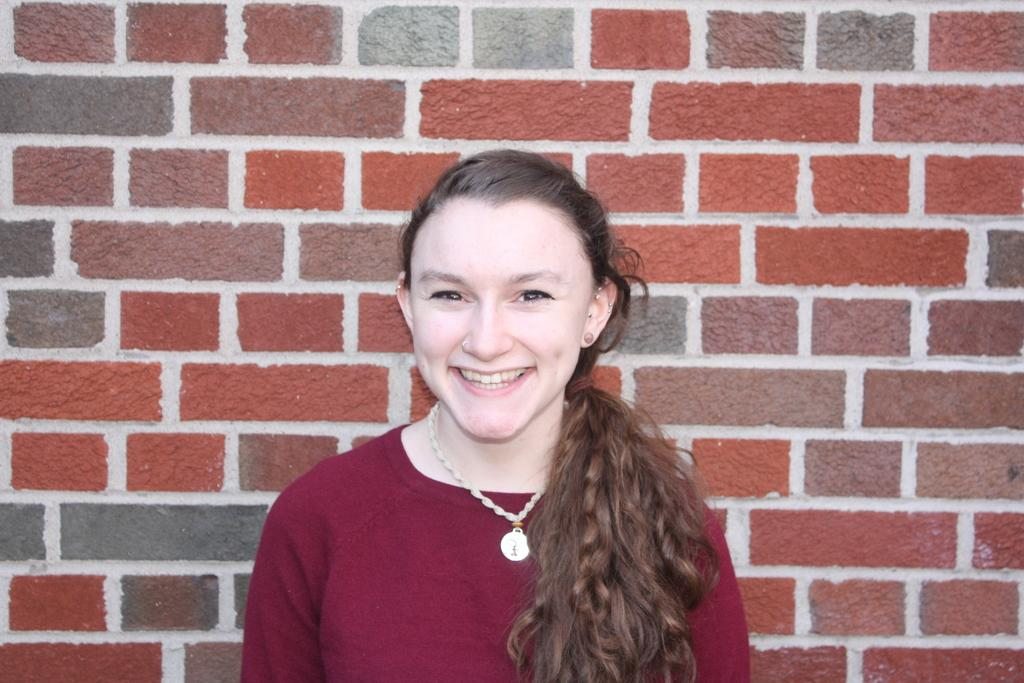What is the main subject of the image? The main subject of the image is a woman. What is the woman doing in the image? The woman is standing in the middle of the image and smiling. What can be seen behind the woman in the image? There is a brick wall behind her. What type of bubble can be seen floating near the woman in the image? There is no bubble present in the image. How many lights are visible on the woman's clothing in the image? The woman's clothing does not have any visible lights in the image. 